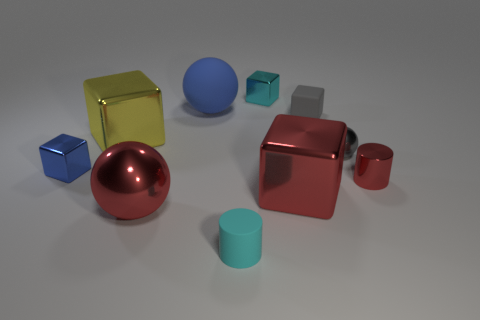What material is the small cube on the left side of the big red metallic object left of the cyan object in front of the metal cylinder?
Your response must be concise. Metal. There is a small cyan object in front of the small red metallic thing; does it have the same shape as the large metallic object behind the small blue object?
Give a very brief answer. No. The shiny ball that is right of the cyan object in front of the tiny shiny cylinder is what color?
Provide a short and direct response. Gray. What number of balls are gray metallic things or tiny cyan shiny things?
Your response must be concise. 1. How many tiny metallic cylinders are on the left side of the shiny object in front of the large red metallic object that is to the right of the red ball?
Your answer should be very brief. 0. There is a block that is the same color as the small ball; what size is it?
Provide a short and direct response. Small. Is there another cube made of the same material as the large yellow cube?
Your answer should be very brief. Yes. Is the red cube made of the same material as the small gray cube?
Offer a terse response. No. There is a metallic block behind the big blue thing; how many metallic spheres are to the left of it?
Provide a succinct answer. 1. What number of red things are either matte blocks or tiny metal cubes?
Ensure brevity in your answer.  0. 